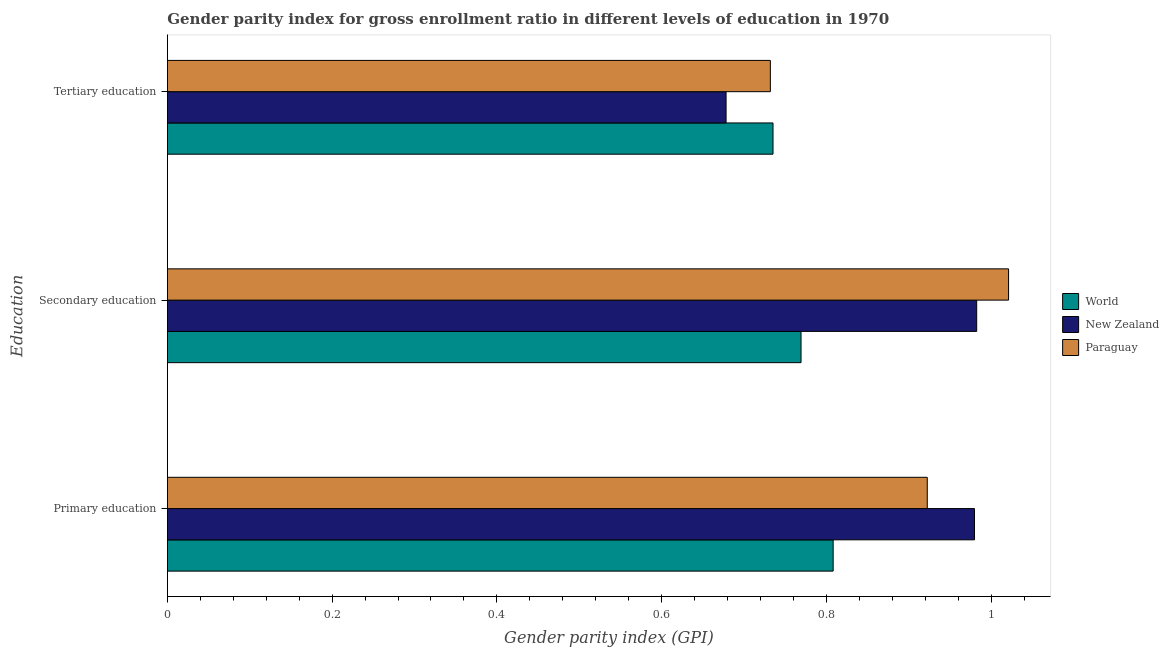How many different coloured bars are there?
Your answer should be compact. 3. What is the label of the 1st group of bars from the top?
Your answer should be compact. Tertiary education. What is the gender parity index in tertiary education in Paraguay?
Your answer should be compact. 0.73. Across all countries, what is the maximum gender parity index in secondary education?
Provide a succinct answer. 1.02. Across all countries, what is the minimum gender parity index in tertiary education?
Offer a very short reply. 0.68. In which country was the gender parity index in tertiary education maximum?
Offer a terse response. World. In which country was the gender parity index in primary education minimum?
Offer a very short reply. World. What is the total gender parity index in tertiary education in the graph?
Your answer should be compact. 2.15. What is the difference between the gender parity index in secondary education in Paraguay and that in New Zealand?
Your answer should be very brief. 0.04. What is the difference between the gender parity index in secondary education in New Zealand and the gender parity index in primary education in World?
Your answer should be very brief. 0.17. What is the average gender parity index in tertiary education per country?
Give a very brief answer. 0.72. What is the difference between the gender parity index in primary education and gender parity index in secondary education in World?
Keep it short and to the point. 0.04. What is the ratio of the gender parity index in primary education in New Zealand to that in Paraguay?
Your answer should be compact. 1.06. What is the difference between the highest and the second highest gender parity index in primary education?
Your answer should be compact. 0.06. What is the difference between the highest and the lowest gender parity index in secondary education?
Provide a succinct answer. 0.25. Is the sum of the gender parity index in secondary education in New Zealand and World greater than the maximum gender parity index in primary education across all countries?
Ensure brevity in your answer.  Yes. What does the 1st bar from the bottom in Primary education represents?
Your answer should be compact. World. How many countries are there in the graph?
Give a very brief answer. 3. Does the graph contain grids?
Your answer should be compact. No. What is the title of the graph?
Provide a succinct answer. Gender parity index for gross enrollment ratio in different levels of education in 1970. Does "Singapore" appear as one of the legend labels in the graph?
Your answer should be very brief. No. What is the label or title of the X-axis?
Make the answer very short. Gender parity index (GPI). What is the label or title of the Y-axis?
Offer a very short reply. Education. What is the Gender parity index (GPI) in World in Primary education?
Keep it short and to the point. 0.81. What is the Gender parity index (GPI) in New Zealand in Primary education?
Provide a succinct answer. 0.98. What is the Gender parity index (GPI) of Paraguay in Primary education?
Provide a short and direct response. 0.92. What is the Gender parity index (GPI) of World in Secondary education?
Keep it short and to the point. 0.77. What is the Gender parity index (GPI) of New Zealand in Secondary education?
Keep it short and to the point. 0.98. What is the Gender parity index (GPI) in Paraguay in Secondary education?
Make the answer very short. 1.02. What is the Gender parity index (GPI) in World in Tertiary education?
Your response must be concise. 0.74. What is the Gender parity index (GPI) of New Zealand in Tertiary education?
Ensure brevity in your answer.  0.68. What is the Gender parity index (GPI) in Paraguay in Tertiary education?
Provide a succinct answer. 0.73. Across all Education, what is the maximum Gender parity index (GPI) in World?
Offer a very short reply. 0.81. Across all Education, what is the maximum Gender parity index (GPI) in New Zealand?
Give a very brief answer. 0.98. Across all Education, what is the maximum Gender parity index (GPI) in Paraguay?
Your response must be concise. 1.02. Across all Education, what is the minimum Gender parity index (GPI) in World?
Make the answer very short. 0.74. Across all Education, what is the minimum Gender parity index (GPI) of New Zealand?
Keep it short and to the point. 0.68. Across all Education, what is the minimum Gender parity index (GPI) in Paraguay?
Give a very brief answer. 0.73. What is the total Gender parity index (GPI) of World in the graph?
Your response must be concise. 2.31. What is the total Gender parity index (GPI) of New Zealand in the graph?
Offer a very short reply. 2.64. What is the total Gender parity index (GPI) of Paraguay in the graph?
Give a very brief answer. 2.68. What is the difference between the Gender parity index (GPI) in World in Primary education and that in Secondary education?
Your response must be concise. 0.04. What is the difference between the Gender parity index (GPI) in New Zealand in Primary education and that in Secondary education?
Your answer should be compact. -0. What is the difference between the Gender parity index (GPI) in Paraguay in Primary education and that in Secondary education?
Ensure brevity in your answer.  -0.1. What is the difference between the Gender parity index (GPI) in World in Primary education and that in Tertiary education?
Provide a short and direct response. 0.07. What is the difference between the Gender parity index (GPI) of New Zealand in Primary education and that in Tertiary education?
Your response must be concise. 0.3. What is the difference between the Gender parity index (GPI) of Paraguay in Primary education and that in Tertiary education?
Ensure brevity in your answer.  0.19. What is the difference between the Gender parity index (GPI) in World in Secondary education and that in Tertiary education?
Provide a short and direct response. 0.03. What is the difference between the Gender parity index (GPI) of New Zealand in Secondary education and that in Tertiary education?
Keep it short and to the point. 0.3. What is the difference between the Gender parity index (GPI) of Paraguay in Secondary education and that in Tertiary education?
Provide a succinct answer. 0.29. What is the difference between the Gender parity index (GPI) in World in Primary education and the Gender parity index (GPI) in New Zealand in Secondary education?
Offer a terse response. -0.17. What is the difference between the Gender parity index (GPI) in World in Primary education and the Gender parity index (GPI) in Paraguay in Secondary education?
Ensure brevity in your answer.  -0.21. What is the difference between the Gender parity index (GPI) in New Zealand in Primary education and the Gender parity index (GPI) in Paraguay in Secondary education?
Provide a succinct answer. -0.04. What is the difference between the Gender parity index (GPI) of World in Primary education and the Gender parity index (GPI) of New Zealand in Tertiary education?
Ensure brevity in your answer.  0.13. What is the difference between the Gender parity index (GPI) in World in Primary education and the Gender parity index (GPI) in Paraguay in Tertiary education?
Provide a succinct answer. 0.08. What is the difference between the Gender parity index (GPI) in New Zealand in Primary education and the Gender parity index (GPI) in Paraguay in Tertiary education?
Offer a very short reply. 0.25. What is the difference between the Gender parity index (GPI) in World in Secondary education and the Gender parity index (GPI) in New Zealand in Tertiary education?
Your response must be concise. 0.09. What is the difference between the Gender parity index (GPI) in World in Secondary education and the Gender parity index (GPI) in Paraguay in Tertiary education?
Ensure brevity in your answer.  0.04. What is the difference between the Gender parity index (GPI) of New Zealand in Secondary education and the Gender parity index (GPI) of Paraguay in Tertiary education?
Give a very brief answer. 0.25. What is the average Gender parity index (GPI) of World per Education?
Keep it short and to the point. 0.77. What is the average Gender parity index (GPI) of New Zealand per Education?
Your response must be concise. 0.88. What is the average Gender parity index (GPI) in Paraguay per Education?
Keep it short and to the point. 0.89. What is the difference between the Gender parity index (GPI) of World and Gender parity index (GPI) of New Zealand in Primary education?
Offer a terse response. -0.17. What is the difference between the Gender parity index (GPI) in World and Gender parity index (GPI) in Paraguay in Primary education?
Give a very brief answer. -0.11. What is the difference between the Gender parity index (GPI) of New Zealand and Gender parity index (GPI) of Paraguay in Primary education?
Provide a short and direct response. 0.06. What is the difference between the Gender parity index (GPI) in World and Gender parity index (GPI) in New Zealand in Secondary education?
Keep it short and to the point. -0.21. What is the difference between the Gender parity index (GPI) in World and Gender parity index (GPI) in Paraguay in Secondary education?
Your answer should be very brief. -0.25. What is the difference between the Gender parity index (GPI) of New Zealand and Gender parity index (GPI) of Paraguay in Secondary education?
Give a very brief answer. -0.04. What is the difference between the Gender parity index (GPI) in World and Gender parity index (GPI) in New Zealand in Tertiary education?
Your answer should be very brief. 0.06. What is the difference between the Gender parity index (GPI) of World and Gender parity index (GPI) of Paraguay in Tertiary education?
Keep it short and to the point. 0. What is the difference between the Gender parity index (GPI) in New Zealand and Gender parity index (GPI) in Paraguay in Tertiary education?
Provide a succinct answer. -0.05. What is the ratio of the Gender parity index (GPI) of World in Primary education to that in Secondary education?
Give a very brief answer. 1.05. What is the ratio of the Gender parity index (GPI) of Paraguay in Primary education to that in Secondary education?
Ensure brevity in your answer.  0.9. What is the ratio of the Gender parity index (GPI) of World in Primary education to that in Tertiary education?
Offer a terse response. 1.1. What is the ratio of the Gender parity index (GPI) of New Zealand in Primary education to that in Tertiary education?
Keep it short and to the point. 1.44. What is the ratio of the Gender parity index (GPI) of Paraguay in Primary education to that in Tertiary education?
Your answer should be very brief. 1.26. What is the ratio of the Gender parity index (GPI) in World in Secondary education to that in Tertiary education?
Your answer should be very brief. 1.05. What is the ratio of the Gender parity index (GPI) in New Zealand in Secondary education to that in Tertiary education?
Make the answer very short. 1.45. What is the ratio of the Gender parity index (GPI) in Paraguay in Secondary education to that in Tertiary education?
Make the answer very short. 1.4. What is the difference between the highest and the second highest Gender parity index (GPI) of World?
Your answer should be compact. 0.04. What is the difference between the highest and the second highest Gender parity index (GPI) in New Zealand?
Give a very brief answer. 0. What is the difference between the highest and the second highest Gender parity index (GPI) in Paraguay?
Provide a short and direct response. 0.1. What is the difference between the highest and the lowest Gender parity index (GPI) in World?
Offer a very short reply. 0.07. What is the difference between the highest and the lowest Gender parity index (GPI) in New Zealand?
Your answer should be compact. 0.3. What is the difference between the highest and the lowest Gender parity index (GPI) in Paraguay?
Offer a very short reply. 0.29. 